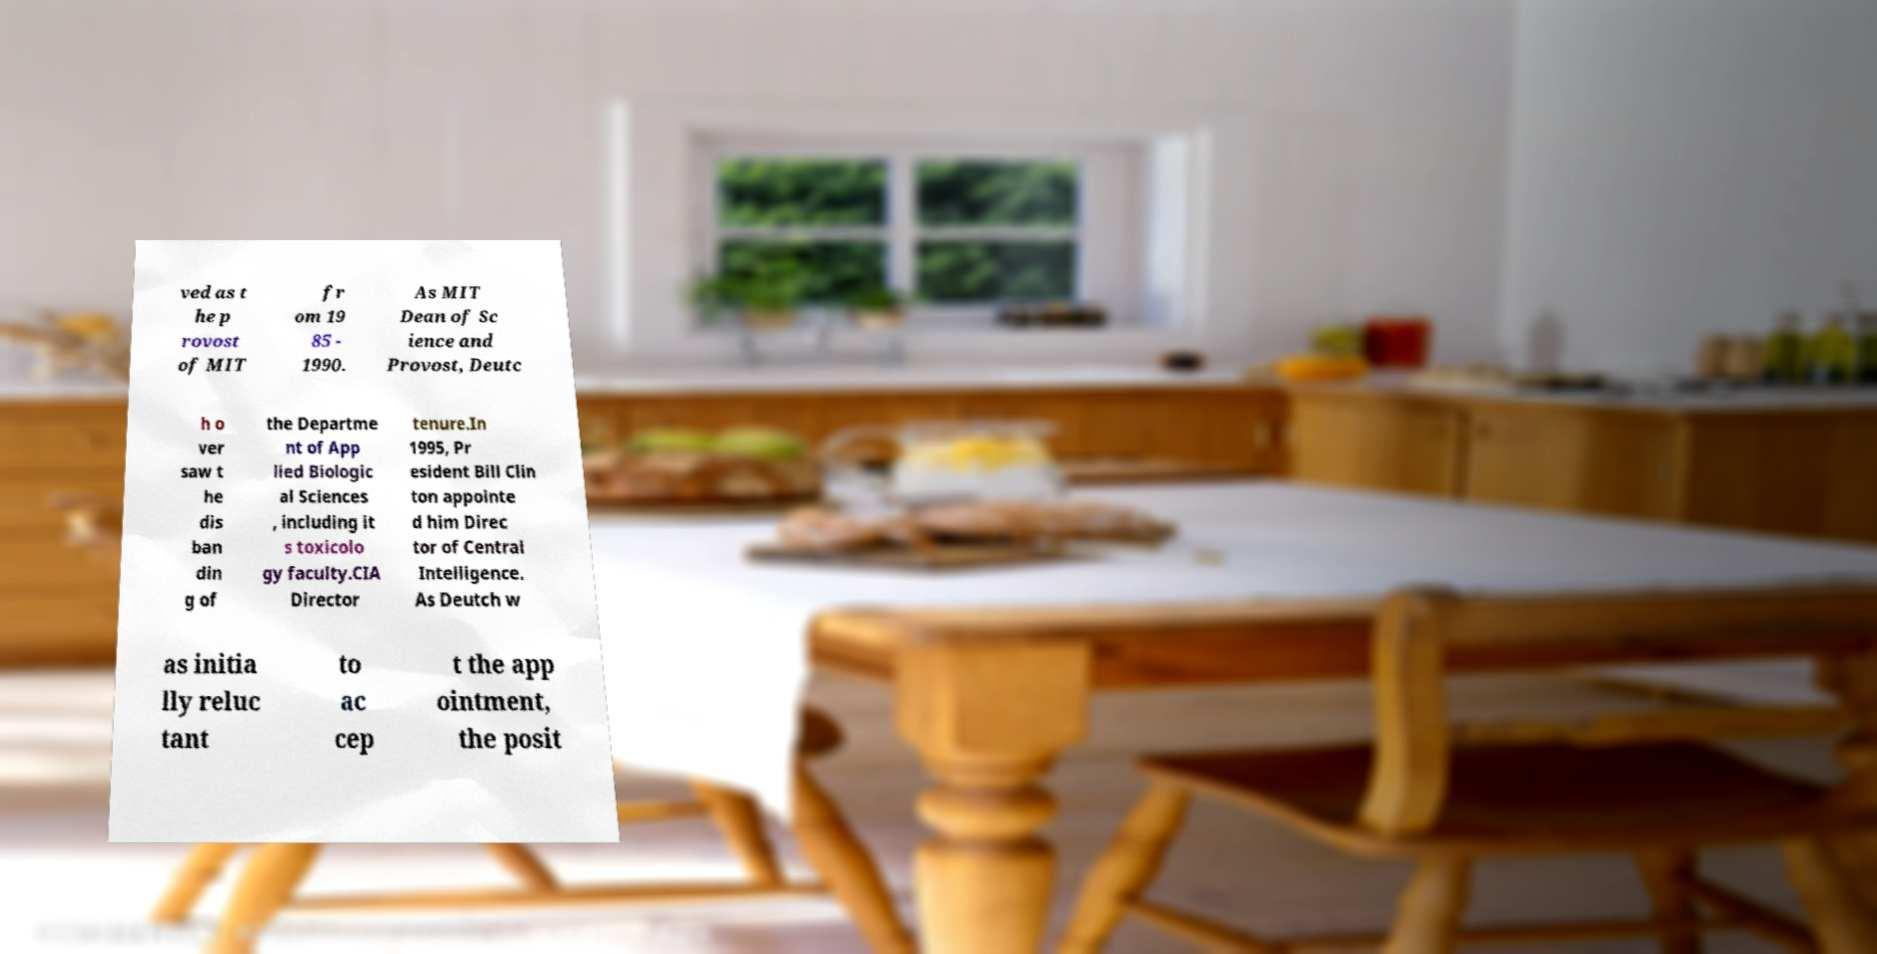Please identify and transcribe the text found in this image. ved as t he p rovost of MIT fr om 19 85 - 1990. As MIT Dean of Sc ience and Provost, Deutc h o ver saw t he dis ban din g of the Departme nt of App lied Biologic al Sciences , including it s toxicolo gy faculty.CIA Director tenure.In 1995, Pr esident Bill Clin ton appointe d him Direc tor of Central Intelligence. As Deutch w as initia lly reluc tant to ac cep t the app ointment, the posit 